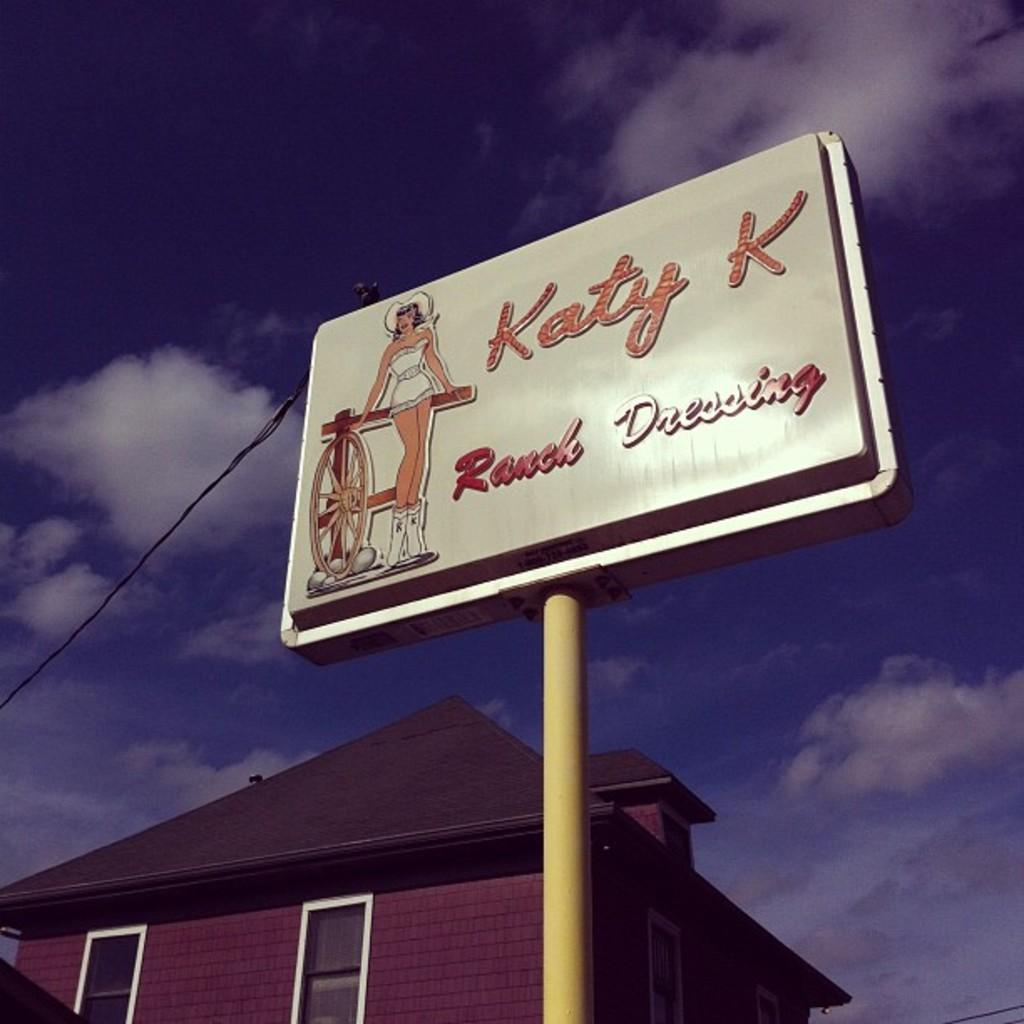What type of structure is present in the image? There is a house in the image. What else can be seen besides the house? There is a yellow color pole in the image, and it has a board attached to it. What is written on the board? There is writing on the board. What can be seen in the background of the image? The sky is visible in the background of the image. How does the jellyfish contribute to the warmth of the house in the image? There is no jellyfish present in the image, and therefore it cannot contribute to the warmth of the house. 